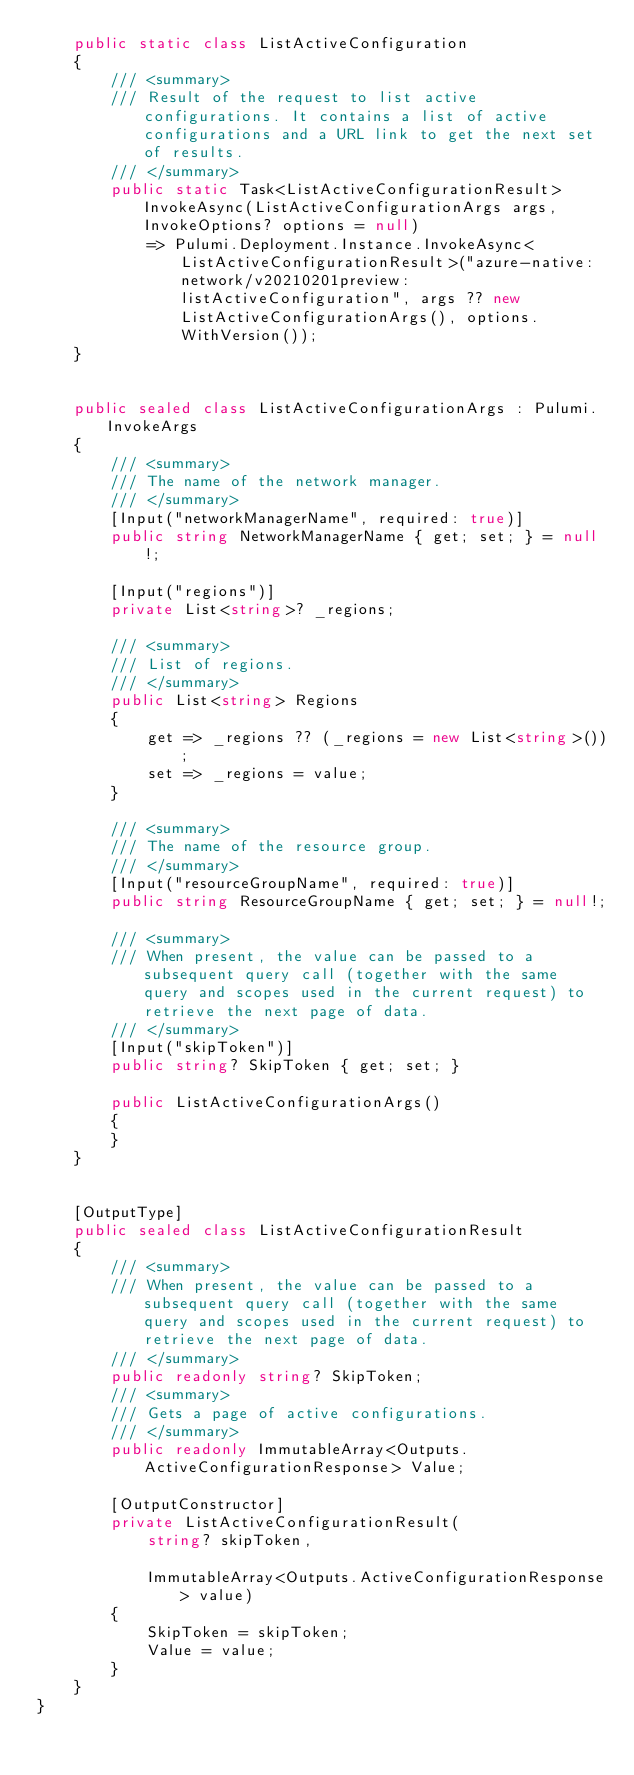<code> <loc_0><loc_0><loc_500><loc_500><_C#_>    public static class ListActiveConfiguration
    {
        /// <summary>
        /// Result of the request to list active configurations. It contains a list of active configurations and a URL link to get the next set of results.
        /// </summary>
        public static Task<ListActiveConfigurationResult> InvokeAsync(ListActiveConfigurationArgs args, InvokeOptions? options = null)
            => Pulumi.Deployment.Instance.InvokeAsync<ListActiveConfigurationResult>("azure-native:network/v20210201preview:listActiveConfiguration", args ?? new ListActiveConfigurationArgs(), options.WithVersion());
    }


    public sealed class ListActiveConfigurationArgs : Pulumi.InvokeArgs
    {
        /// <summary>
        /// The name of the network manager.
        /// </summary>
        [Input("networkManagerName", required: true)]
        public string NetworkManagerName { get; set; } = null!;

        [Input("regions")]
        private List<string>? _regions;

        /// <summary>
        /// List of regions.
        /// </summary>
        public List<string> Regions
        {
            get => _regions ?? (_regions = new List<string>());
            set => _regions = value;
        }

        /// <summary>
        /// The name of the resource group.
        /// </summary>
        [Input("resourceGroupName", required: true)]
        public string ResourceGroupName { get; set; } = null!;

        /// <summary>
        /// When present, the value can be passed to a subsequent query call (together with the same query and scopes used in the current request) to retrieve the next page of data.
        /// </summary>
        [Input("skipToken")]
        public string? SkipToken { get; set; }

        public ListActiveConfigurationArgs()
        {
        }
    }


    [OutputType]
    public sealed class ListActiveConfigurationResult
    {
        /// <summary>
        /// When present, the value can be passed to a subsequent query call (together with the same query and scopes used in the current request) to retrieve the next page of data.
        /// </summary>
        public readonly string? SkipToken;
        /// <summary>
        /// Gets a page of active configurations.
        /// </summary>
        public readonly ImmutableArray<Outputs.ActiveConfigurationResponse> Value;

        [OutputConstructor]
        private ListActiveConfigurationResult(
            string? skipToken,

            ImmutableArray<Outputs.ActiveConfigurationResponse> value)
        {
            SkipToken = skipToken;
            Value = value;
        }
    }
}
</code> 